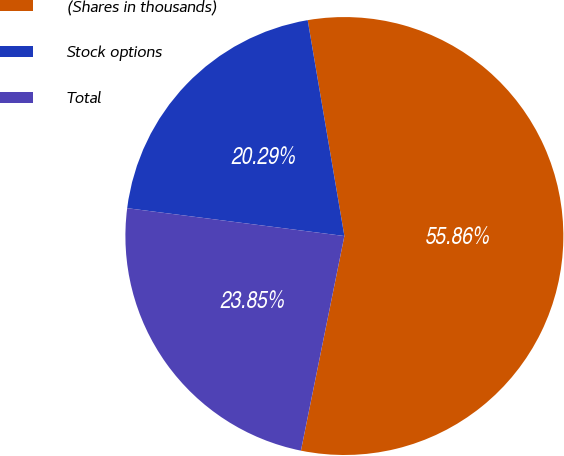Convert chart. <chart><loc_0><loc_0><loc_500><loc_500><pie_chart><fcel>(Shares in thousands)<fcel>Stock options<fcel>Total<nl><fcel>55.86%<fcel>20.29%<fcel>23.85%<nl></chart> 